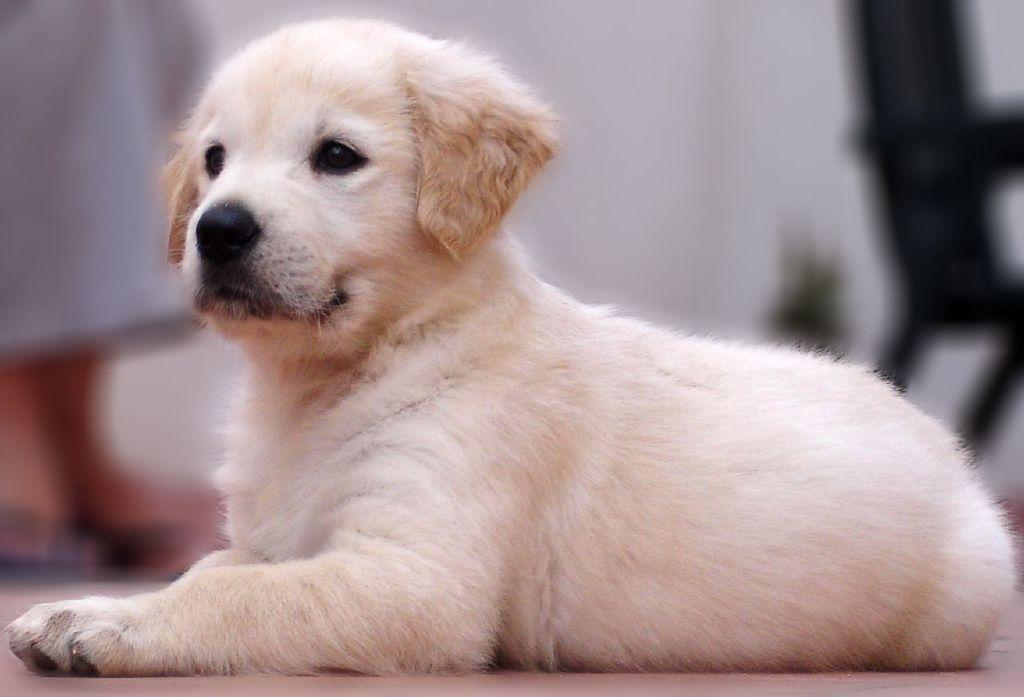What is the main subject in the center of the image? There is a dog in the center of the image. Can you describe the person in the background of the image? There is a person standing in the background of the image. What object is also present in the background of the image? There is a chair in the background of the image. What type of disease is the dog suffering from in the image? There is no indication of any disease in the image; the dog appears to be healthy. 